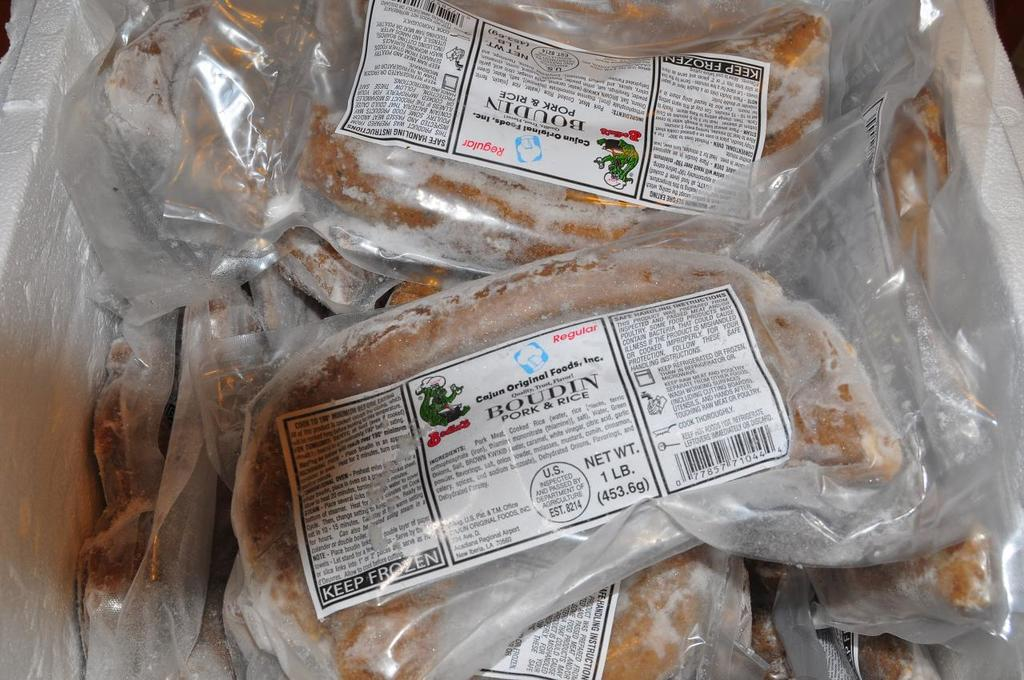What type of items can be seen in the image? There are food items in the image. How are the food items packaged? The food items are packed with plastic covers. What else is present in the image besides the food items? There are papers in the image. Can you see a fireman putting out a stream of water in the image? No, there is no fireman or stream of water present in the image. 